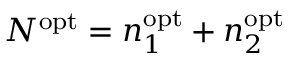<formula> <loc_0><loc_0><loc_500><loc_500>N ^ { o p t } = n _ { 1 } ^ { o p t } + n _ { 2 } ^ { o p t }</formula> 